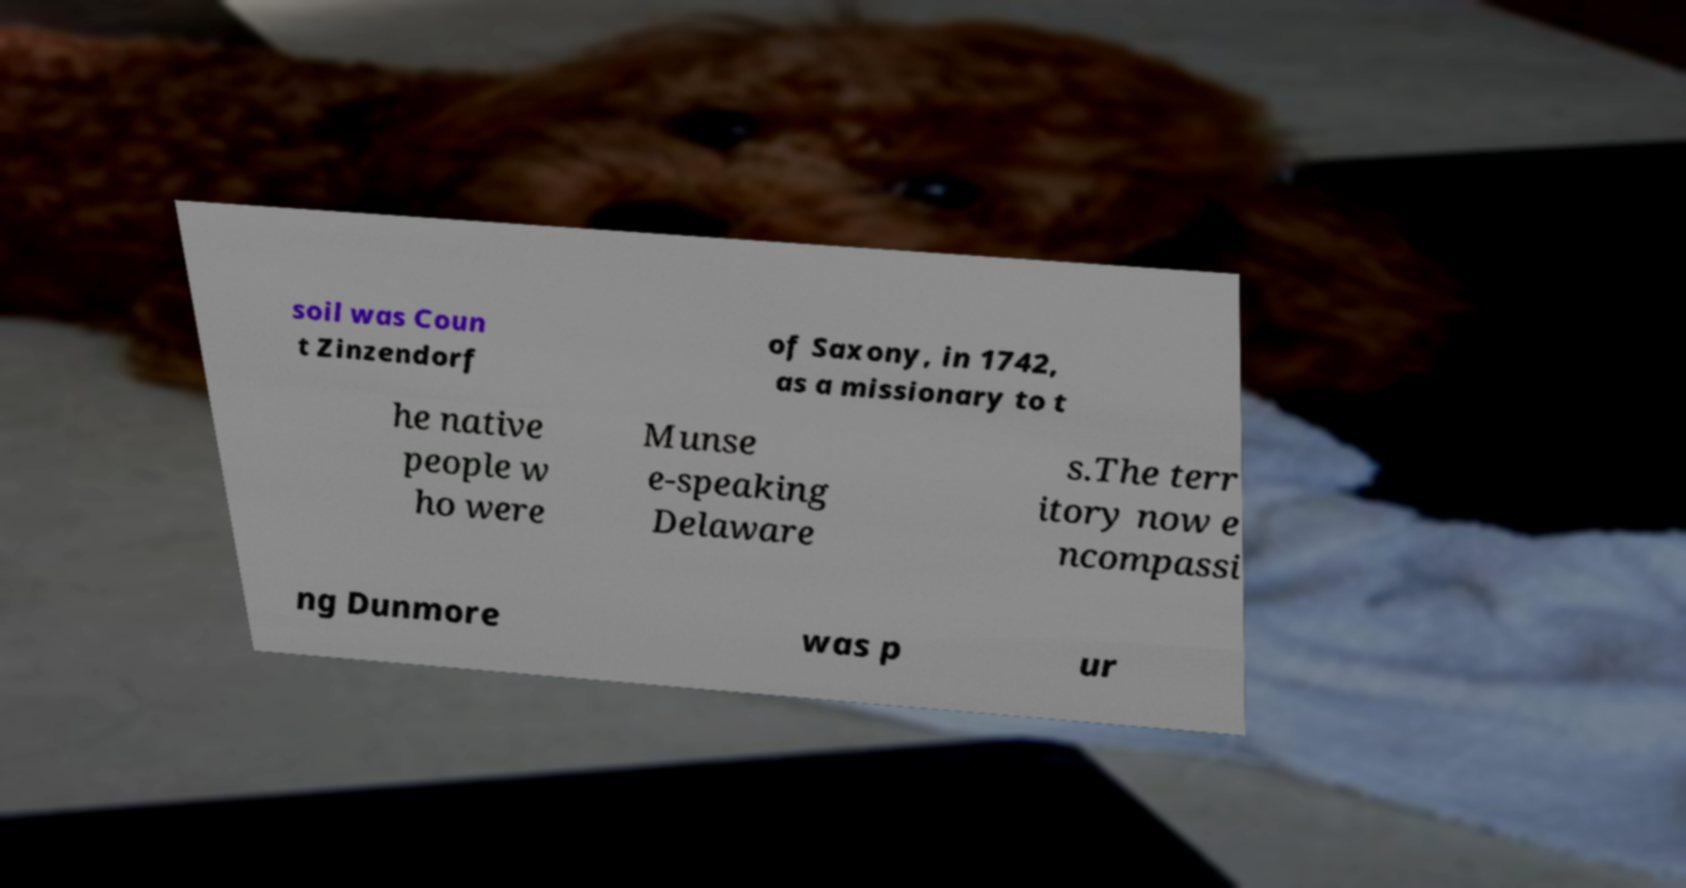Can you accurately transcribe the text from the provided image for me? soil was Coun t Zinzendorf of Saxony, in 1742, as a missionary to t he native people w ho were Munse e-speaking Delaware s.The terr itory now e ncompassi ng Dunmore was p ur 